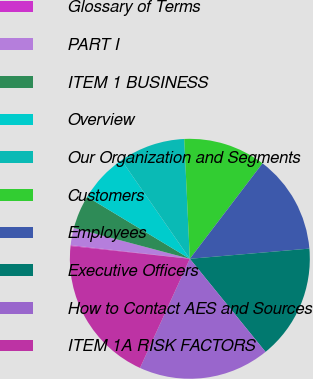Convert chart to OTSL. <chart><loc_0><loc_0><loc_500><loc_500><pie_chart><fcel>Glossary of Terms<fcel>PART I<fcel>ITEM 1 BUSINESS<fcel>Overview<fcel>Our Organization and Segments<fcel>Customers<fcel>Employees<fcel>Executive Officers<fcel>How to Contact AES and Sources<fcel>ITEM 1A RISK FACTORS<nl><fcel>0.12%<fcel>2.32%<fcel>4.51%<fcel>6.71%<fcel>8.9%<fcel>11.1%<fcel>13.29%<fcel>15.49%<fcel>17.68%<fcel>19.88%<nl></chart> 